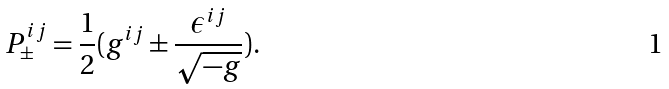<formula> <loc_0><loc_0><loc_500><loc_500>P _ { \pm } ^ { i j } = \frac { 1 } { 2 } ( g ^ { i j } \pm \frac { \epsilon ^ { i j } } { \sqrt { - g } } ) .</formula> 